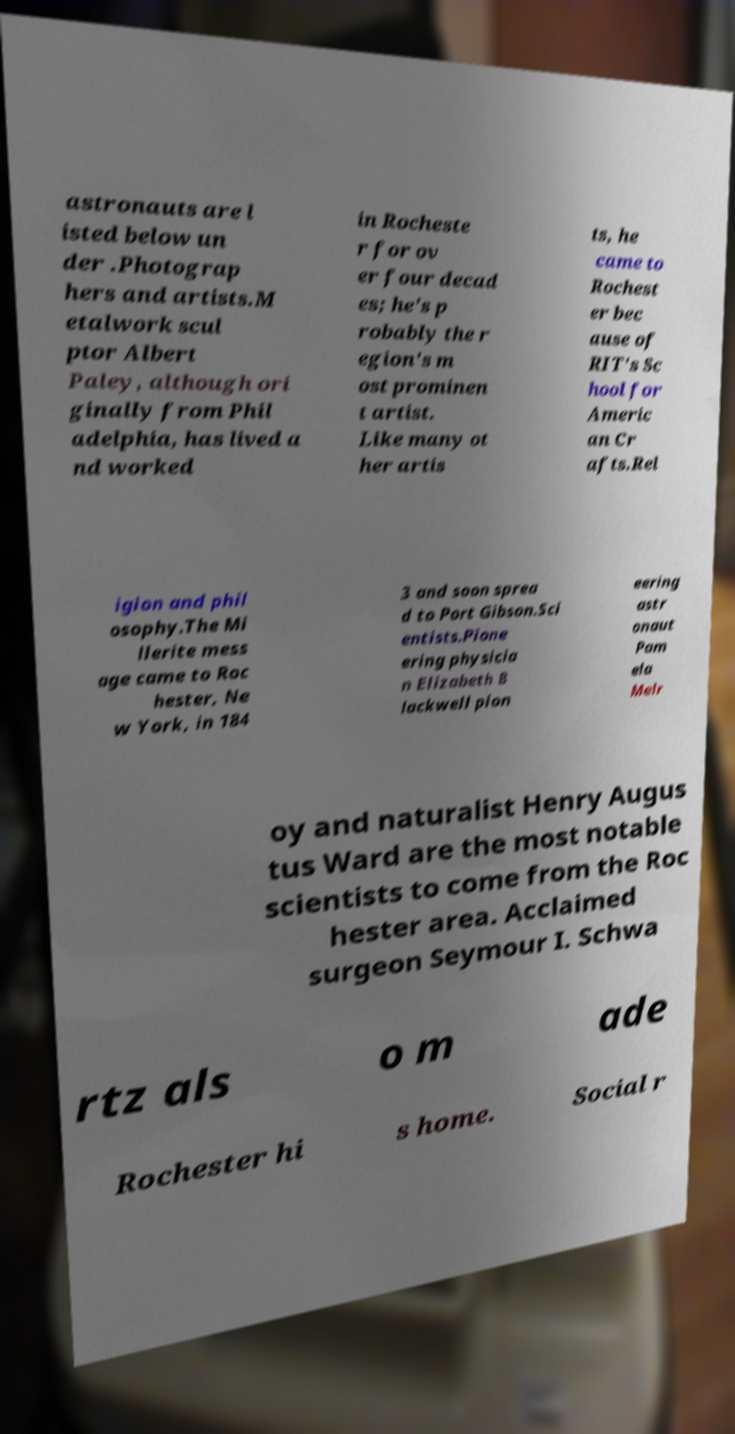Can you accurately transcribe the text from the provided image for me? astronauts are l isted below un der .Photograp hers and artists.M etalwork scul ptor Albert Paley, although ori ginally from Phil adelphia, has lived a nd worked in Rocheste r for ov er four decad es; he's p robably the r egion's m ost prominen t artist. Like many ot her artis ts, he came to Rochest er bec ause of RIT's Sc hool for Americ an Cr afts.Rel igion and phil osophy.The Mi llerite mess age came to Roc hester, Ne w York, in 184 3 and soon sprea d to Port Gibson.Sci entists.Pione ering physicia n Elizabeth B lackwell pion eering astr onaut Pam ela Melr oy and naturalist Henry Augus tus Ward are the most notable scientists to come from the Roc hester area. Acclaimed surgeon Seymour I. Schwa rtz als o m ade Rochester hi s home. Social r 